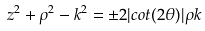<formula> <loc_0><loc_0><loc_500><loc_500>z ^ { 2 } + \rho ^ { 2 } - k ^ { 2 } = \pm 2 | c o t ( 2 \theta ) | \rho k</formula> 